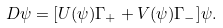Convert formula to latex. <formula><loc_0><loc_0><loc_500><loc_500>\ D \psi = [ U ( \psi ) \Gamma _ { + } + V ( \psi ) \Gamma _ { - } ] \psi .</formula> 